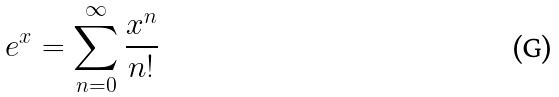Convert formula to latex. <formula><loc_0><loc_0><loc_500><loc_500>e ^ { x } = \sum _ { n = 0 } ^ { \infty } \frac { x ^ { n } } { n ! }</formula> 